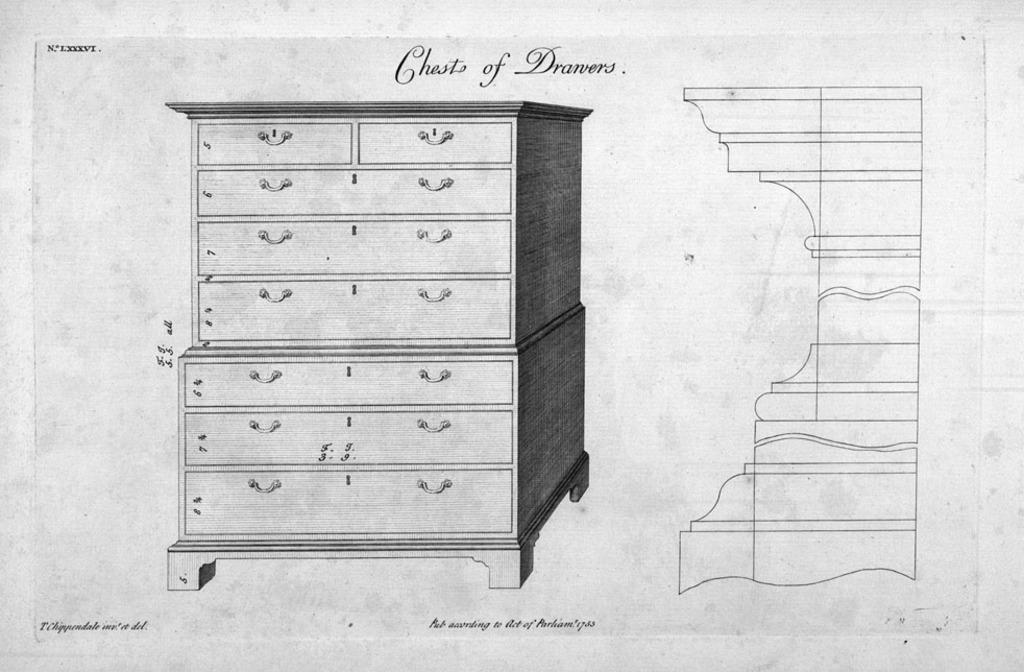What is the main subject of the image? The main subject of the image is a sketch of a cupboard. Are there any additional details on the image? Yes, there is writing on the image. What is the color scheme of the image? The image is black and white in color. Can you tell me what scene is depicted on the receipt in the image? There is no receipt present in the image, and therefore no scene can be depicted on it. 